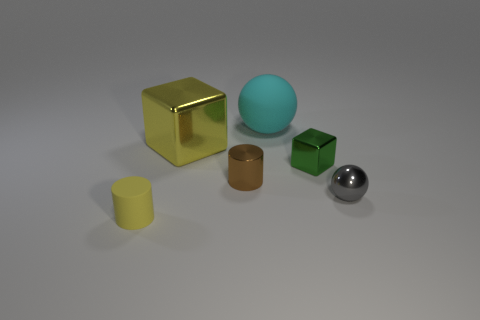How many other objects are there of the same color as the rubber cylinder?
Your answer should be compact. 1. There is a cyan object that is the same size as the yellow block; what shape is it?
Give a very brief answer. Sphere. How many large things are either purple metal blocks or gray shiny objects?
Your answer should be compact. 0. There is a big yellow metal block on the left side of the matte object to the right of the tiny yellow rubber cylinder; is there a big yellow object behind it?
Keep it short and to the point. No. Are there any green balls that have the same size as the gray ball?
Your answer should be very brief. No. What material is the thing that is the same size as the cyan ball?
Keep it short and to the point. Metal. There is a green metal thing; does it have the same size as the rubber thing that is to the right of the big metal cube?
Offer a very short reply. No. How many metal objects are either brown things or gray balls?
Ensure brevity in your answer.  2. How many tiny yellow matte things are the same shape as the tiny brown thing?
Provide a succinct answer. 1. What material is the cylinder that is the same color as the large cube?
Make the answer very short. Rubber. 